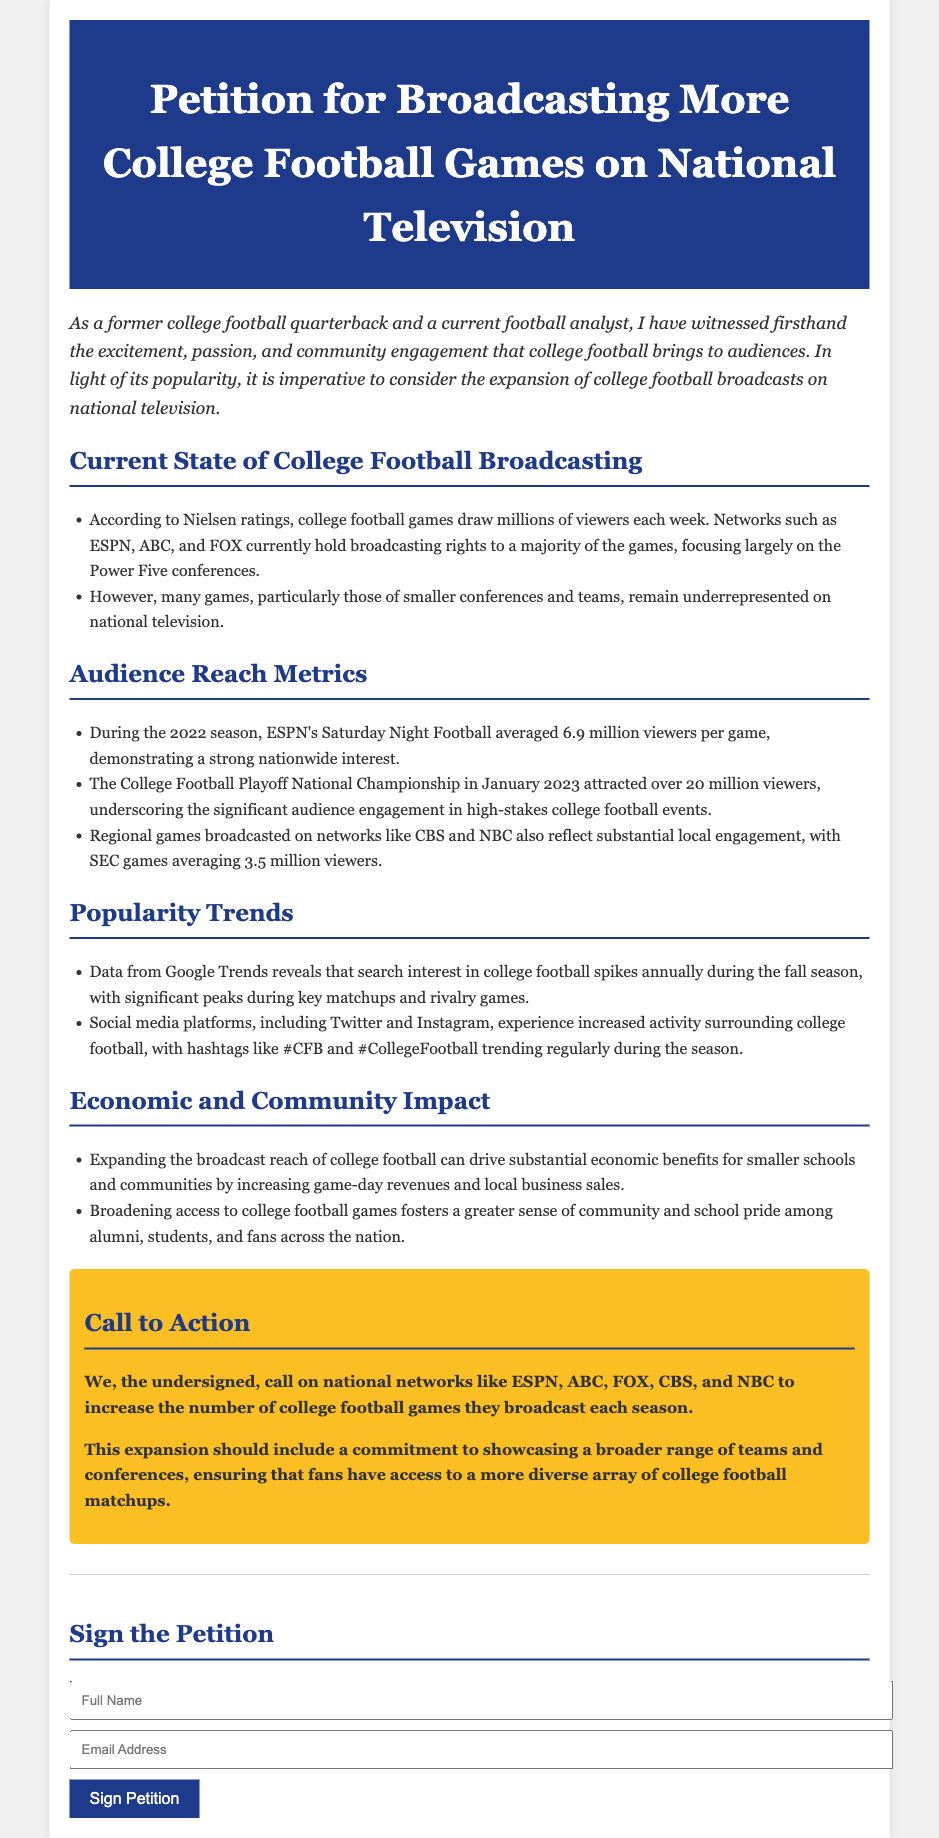What was the average viewership for ESPN's Saturday Night Football in 2022? The document states that during the 2022 season, ESPN's Saturday Night Football averaged 6.9 million viewers per game.
Answer: 6.9 million viewers What significant event attracted over 20 million viewers? According to the document, the College Football Playoff National Championship in January 2023 attracted over 20 million viewers.
Answer: College Football Playoff National Championship Which networks currently hold broadcasting rights to most college football games? The document mentions that networks such as ESPN, ABC, and FOX currently hold broadcasting rights to a majority of the games.
Answer: ESPN, ABC, FOX What hashtag trends regularly during the college football season? The document indicates that hashtags like #CFB and #CollegeFootball trend regularly during the season.
Answer: #CFB, #CollegeFootball What economic benefit can arise from expanding college football broadcasts? The document states that expanding the broadcast reach can drive substantial economic benefits for smaller schools and communities.
Answer: Economic benefits How do social media platforms respond during the college football season? The document reveals that social media platforms experience increased activity surrounding college football during the season.
Answer: Increased activity What is the primary call to action stated in the petition? The document calls on national networks to increase the number of college football games they broadcast each season.
Answer: Increase the number of broadcasts What conference's games averaged 3.5 million viewers? According to the document, SEC games averaged 3.5 million viewers.
Answer: SEC games What season does search interest in college football typically spike? The document mentions that search interest in college football spikes annually during the fall season.
Answer: Fall season 